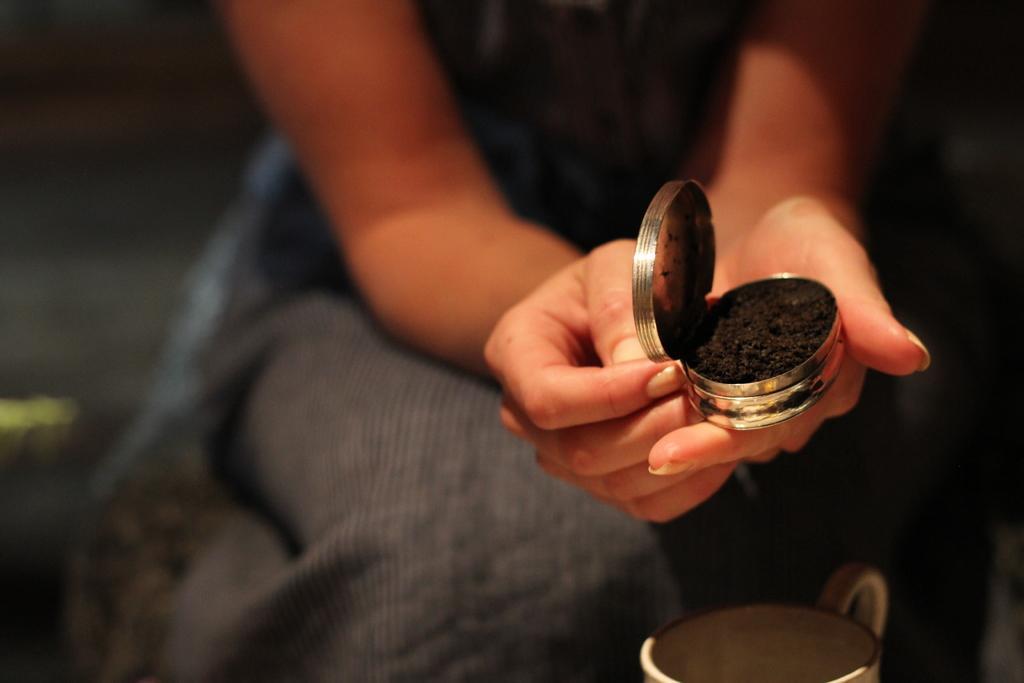Please provide a concise description of this image. In this image there is a woman who is holding the small box. In the box there is black colour powder. At the bottom there is cup. 